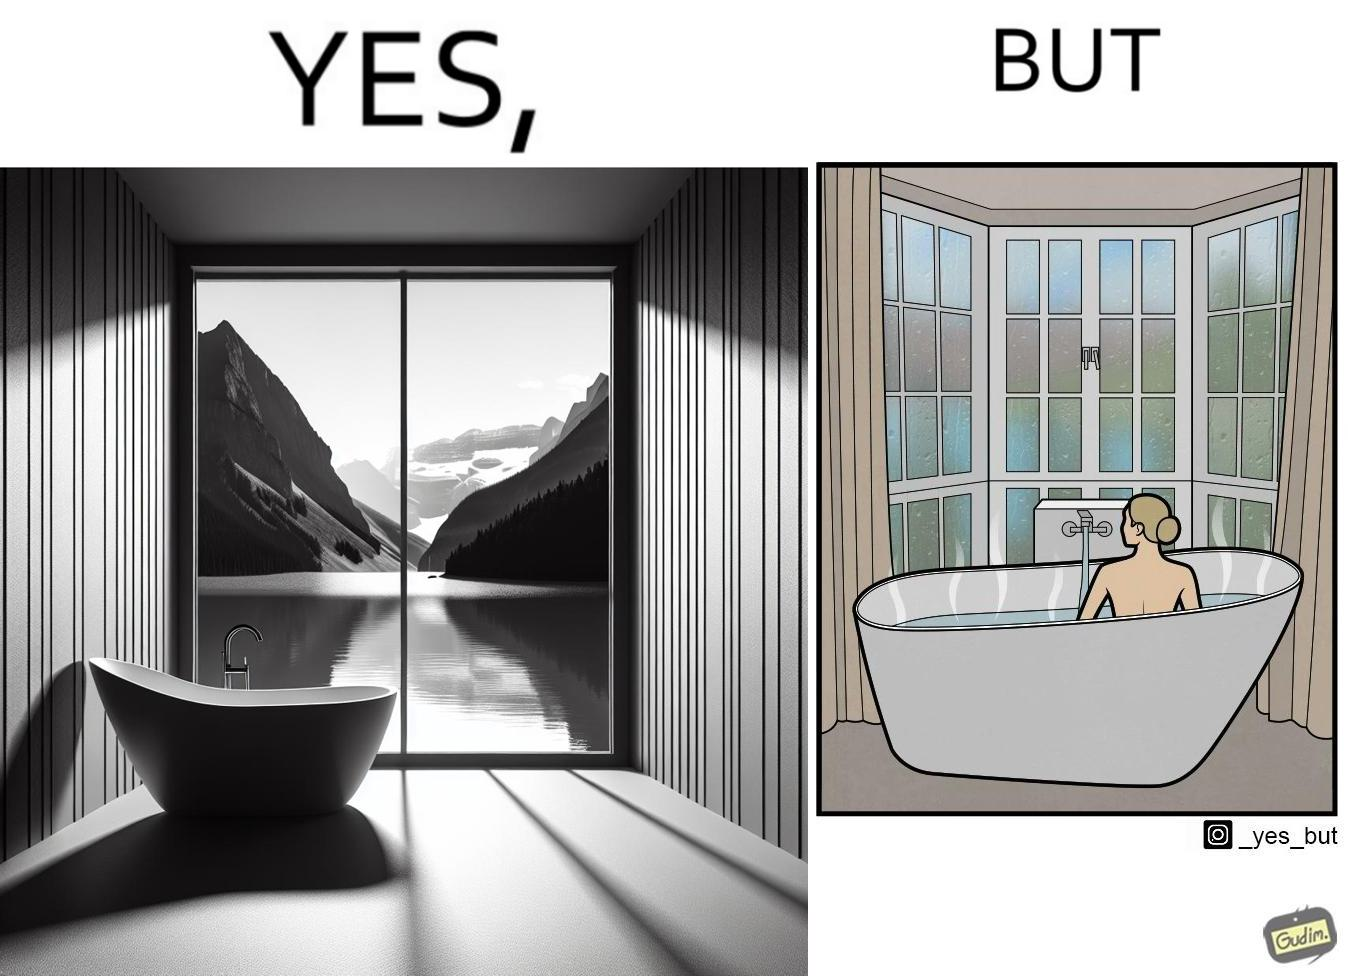Describe the contrast between the left and right parts of this image. In the left part of the image: a bathtub by the side of a window which has a very scenic view of lake and mountains. In the right part of the image: a woman bathing in a bathtub, while the window glasses are foggy from the steam of the hot water. 